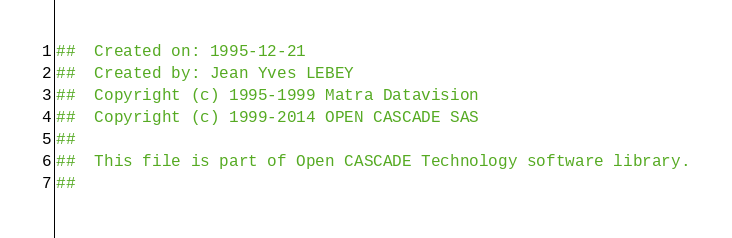Convert code to text. <code><loc_0><loc_0><loc_500><loc_500><_Nim_>##  Created on: 1995-12-21
##  Created by: Jean Yves LEBEY
##  Copyright (c) 1995-1999 Matra Datavision
##  Copyright (c) 1999-2014 OPEN CASCADE SAS
##
##  This file is part of Open CASCADE Technology software library.
##</code> 